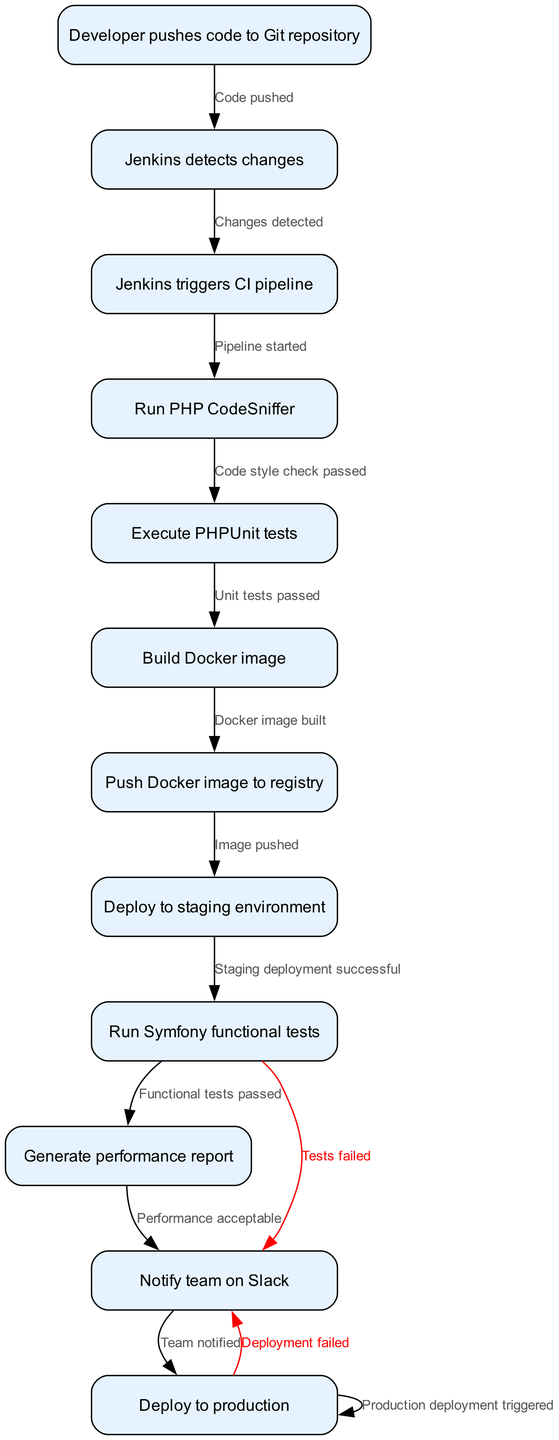What's the first step in the CI/CD workflow? The diagram starts with the node "Developer pushes code to Git repository," indicating that this is the first action in the CI/CD process.
Answer: Developer pushes code to Git repository How many nodes are in this diagram? The diagram consists of a total of 11 nodes that represent distinct activities or processes in the CI/CD workflow, specifically related to Jenkins and Docker.
Answer: 11 What is the last action before deploying to production? Before the final production deployment occurs, the step "Team notified" is completed, which is necessary to inform the team about the successful outcomes of previous steps.
Answer: Team notified If the PHPUnit tests fail, what happens next? According to the diagram, if the "Unit tests passed" condition is not met, there will be a failure that leads to a notification to the team; hence, the flow moves to the "Tests failed" edge.
Answer: Tests failed How does the pipeline react when the Docker image is built? Once the "Docker image built" step is completed successfully, it transitions to the "Image pushed" node, thereby continuing the workflow without interruption.
Answer: Image pushed What indicates a failure in the deployment process? The diagram specifies that if the deployment fails at any point, it is marked with the "Deployment failed" edge, which signals an error occurred during the deployment phase to production.
Answer: Deployment failed Which step occurs after Jenkins triggers the CI pipeline? Following the "Jenkins triggers CI pipeline" step, the next activity is "Run PHP CodeSniffer," which checks the code's adherence to a set coding standard.
Answer: Run PHP CodeSniffer How many edges are present in the diagram? By reviewing the connections between nodes, there are 12 edge entries that represent different transitions or conditions leading from one node to another in the CI/CD process.
Answer: 12 